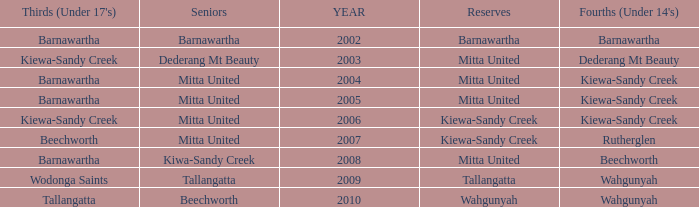Which Thirds (Under 17's) have a Reserve of barnawartha? Barnawartha. 